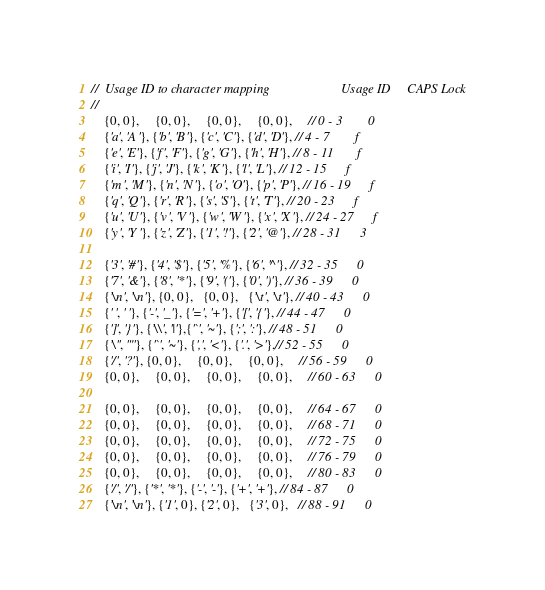<code> <loc_0><loc_0><loc_500><loc_500><_C_>//  Usage ID to character mapping                      Usage ID     CAPS Lock
//
    {0, 0},     {0, 0},     {0, 0},     {0, 0},     // 0 - 3        0
    {'a', 'A'}, {'b', 'B'}, {'c', 'C'}, {'d', 'D'}, // 4 - 7        f
    {'e', 'E'}, {'f', 'F'}, {'g', 'G'}, {'h', 'H'}, // 8 - 11       f
    {'i', 'I'}, {'j', 'J'}, {'k', 'K'}, {'l', 'L'}, // 12 - 15      f
    {'m', 'M'}, {'n', 'N'}, {'o', 'O'}, {'p', 'P'}, // 16 - 19      f
    {'q', 'Q'}, {'r', 'R'}, {'s', 'S'}, {'t', 'T'}, // 20 - 23      f
    {'u', 'U'}, {'v', 'V'}, {'w', 'W'}, {'x', 'X'}, // 24 - 27      f
    {'y', 'Y'}, {'z', 'Z'}, {'1', '!'}, {'2', '@'}, // 28 - 31      3

    {'3', '#'}, {'4', '$'}, {'5', '%'}, {'6', '^'}, // 32 - 35      0
    {'7', '&'}, {'8', '*'}, {'9', '('}, {'0', ')'}, // 36 - 39      0
    {'\n', '\n'}, {0, 0},   {0, 0},   {'\t', '\t'}, // 40 - 43      0
    {' ', ' '}, {'-', '_'}, {'=', '+'}, {'[', '{'}, // 44 - 47      0
    {']', '}'}, {'\\', '|'},{'`', '~'}, {';', ':'}, // 48 - 51      0
    {'\'', '"'}, {'`', '~'}, {',', '<'}, {'.', '>'},// 52 - 55      0
    {'/', '?'}, {0, 0},     {0, 0},     {0, 0},     // 56 - 59      0
    {0, 0},     {0, 0},     {0, 0},     {0, 0},     // 60 - 63      0

    {0, 0},     {0, 0},     {0, 0},     {0, 0},     // 64 - 67      0
    {0, 0},     {0, 0},     {0, 0},     {0, 0},     // 68 - 71      0
    {0, 0},     {0, 0},     {0, 0},     {0, 0},     // 72 - 75      0
    {0, 0},     {0, 0},     {0, 0},     {0, 0},     // 76 - 79      0
    {0, 0},     {0, 0},     {0, 0},     {0, 0},     // 80 - 83      0
    {'/', '/'}, {'*', '*'}, {'-', '-'}, {'+', '+'}, // 84 - 87      0
    {'\n', '\n'}, {'1', 0}, {'2', 0},   {'3', 0},   // 88 - 91      0</code> 